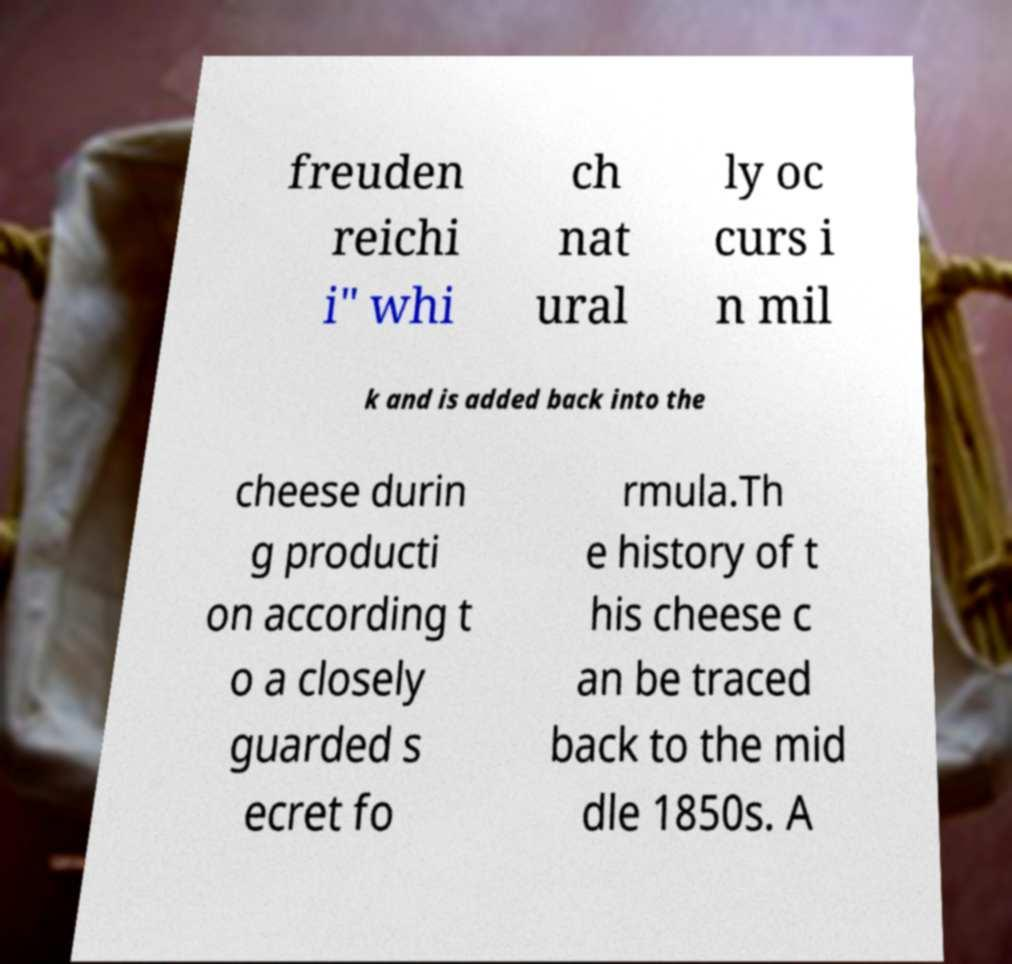Please read and relay the text visible in this image. What does it say? freuden reichi i" whi ch nat ural ly oc curs i n mil k and is added back into the cheese durin g producti on according t o a closely guarded s ecret fo rmula.Th e history of t his cheese c an be traced back to the mid dle 1850s. A 